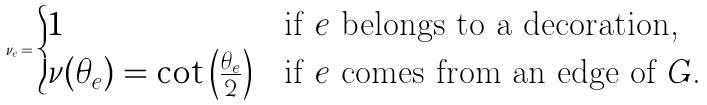Convert formula to latex. <formula><loc_0><loc_0><loc_500><loc_500>\nu _ { e } = \begin{cases} 1 & \text {if $e$ belongs to a decoration,} \\ \nu ( \theta _ { e } ) = \cot \left ( \frac { \theta _ { e } } { 2 } \right ) & \text {if $e$ comes from an edge of $G$.} \end{cases}</formula> 